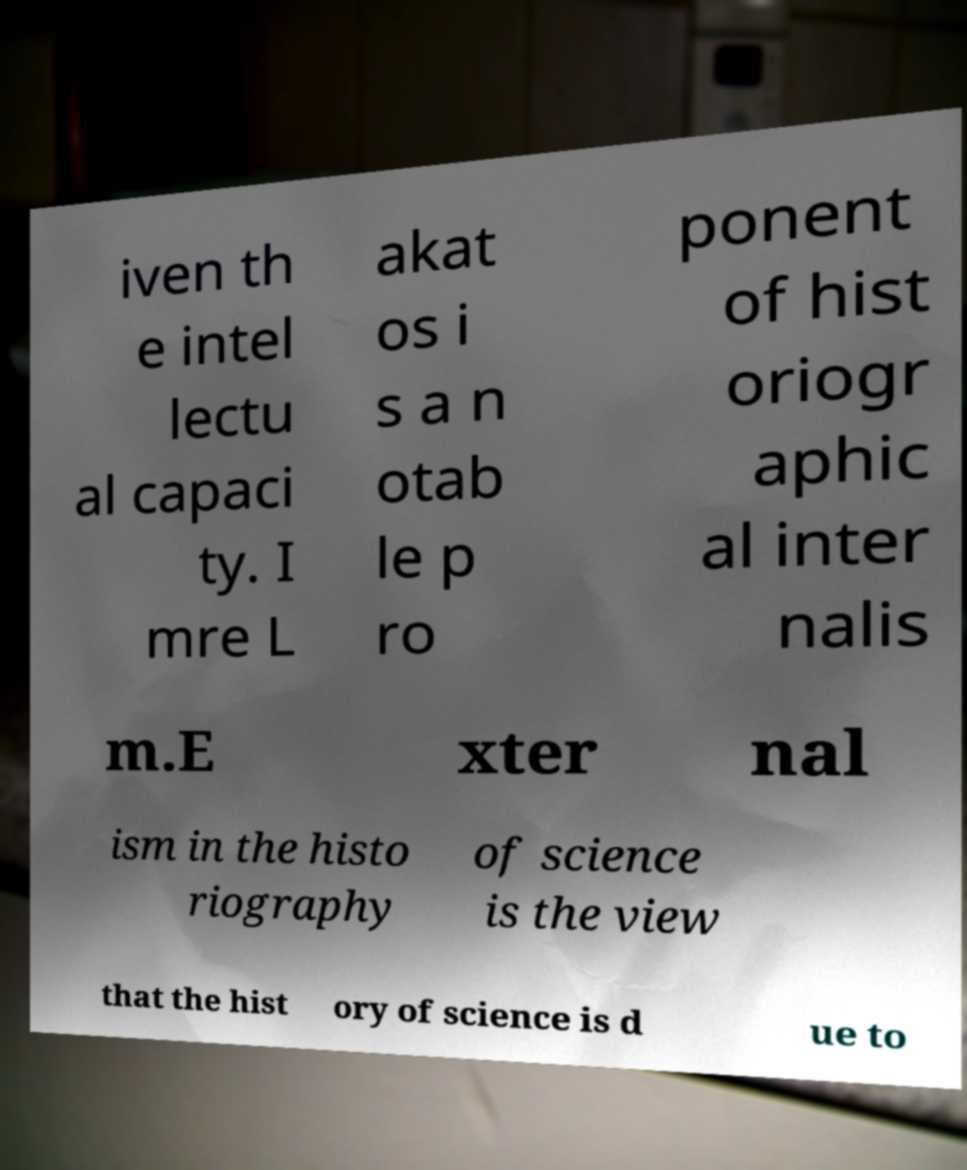Please read and relay the text visible in this image. What does it say? iven th e intel lectu al capaci ty. I mre L akat os i s a n otab le p ro ponent of hist oriogr aphic al inter nalis m.E xter nal ism in the histo riography of science is the view that the hist ory of science is d ue to 